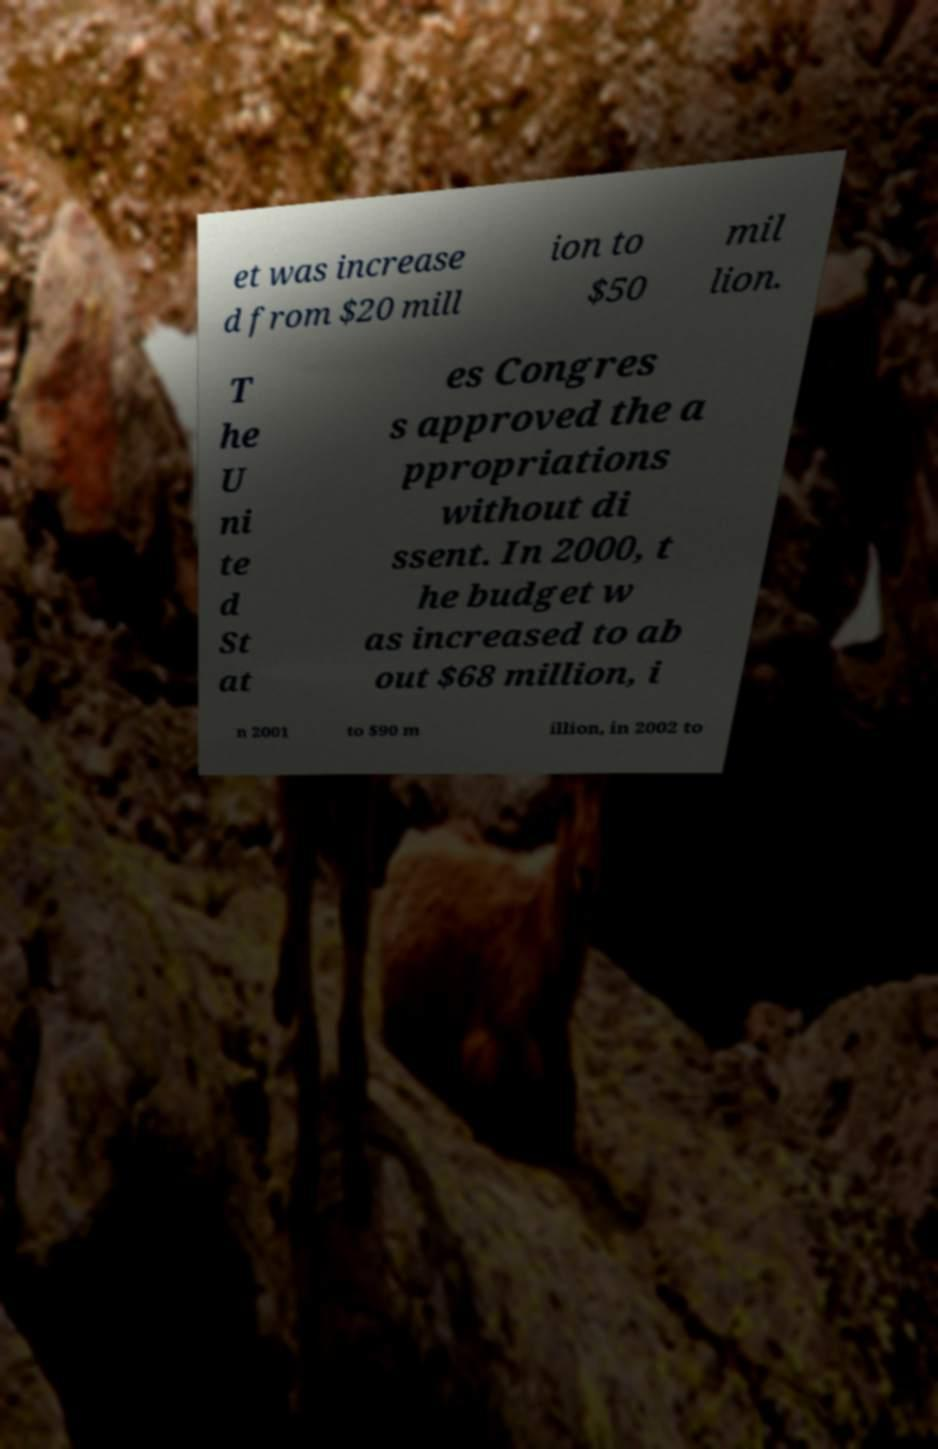Could you extract and type out the text from this image? et was increase d from $20 mill ion to $50 mil lion. T he U ni te d St at es Congres s approved the a ppropriations without di ssent. In 2000, t he budget w as increased to ab out $68 million, i n 2001 to $90 m illion, in 2002 to 